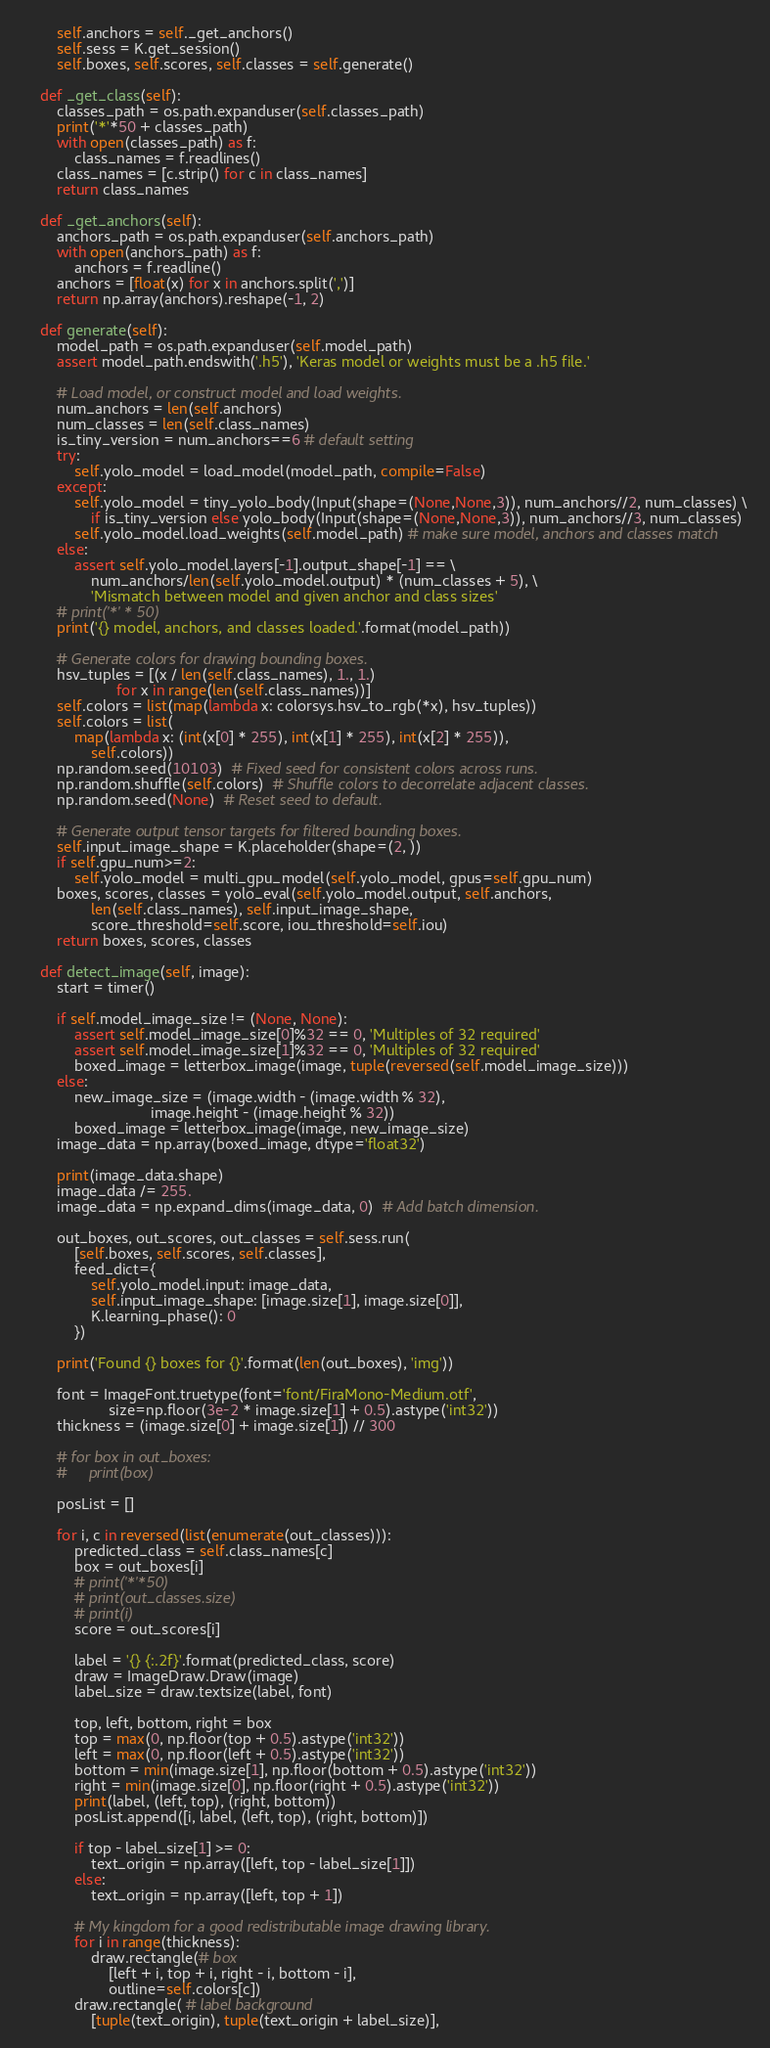Convert code to text. <code><loc_0><loc_0><loc_500><loc_500><_Python_>        self.anchors = self._get_anchors()
        self.sess = K.get_session()
        self.boxes, self.scores, self.classes = self.generate()

    def _get_class(self):
        classes_path = os.path.expanduser(self.classes_path)
        print('*'*50 + classes_path)
        with open(classes_path) as f:
            class_names = f.readlines()
        class_names = [c.strip() for c in class_names]
        return class_names

    def _get_anchors(self):
        anchors_path = os.path.expanduser(self.anchors_path)
        with open(anchors_path) as f:
            anchors = f.readline()
        anchors = [float(x) for x in anchors.split(',')]
        return np.array(anchors).reshape(-1, 2)

    def generate(self):
        model_path = os.path.expanduser(self.model_path)
        assert model_path.endswith('.h5'), 'Keras model or weights must be a .h5 file.'

        # Load model, or construct model and load weights.
        num_anchors = len(self.anchors)
        num_classes = len(self.class_names)
        is_tiny_version = num_anchors==6 # default setting
        try:
            self.yolo_model = load_model(model_path, compile=False)
        except:
            self.yolo_model = tiny_yolo_body(Input(shape=(None,None,3)), num_anchors//2, num_classes) \
                if is_tiny_version else yolo_body(Input(shape=(None,None,3)), num_anchors//3, num_classes)
            self.yolo_model.load_weights(self.model_path) # make sure model, anchors and classes match
        else:
            assert self.yolo_model.layers[-1].output_shape[-1] == \
                num_anchors/len(self.yolo_model.output) * (num_classes + 5), \
                'Mismatch between model and given anchor and class sizes'
        # print('*' * 50)
        print('{} model, anchors, and classes loaded.'.format(model_path))

        # Generate colors for drawing bounding boxes.
        hsv_tuples = [(x / len(self.class_names), 1., 1.)
                      for x in range(len(self.class_names))]
        self.colors = list(map(lambda x: colorsys.hsv_to_rgb(*x), hsv_tuples))
        self.colors = list(
            map(lambda x: (int(x[0] * 255), int(x[1] * 255), int(x[2] * 255)),
                self.colors))
        np.random.seed(10103)  # Fixed seed for consistent colors across runs.
        np.random.shuffle(self.colors)  # Shuffle colors to decorrelate adjacent classes.
        np.random.seed(None)  # Reset seed to default.

        # Generate output tensor targets for filtered bounding boxes.
        self.input_image_shape = K.placeholder(shape=(2, ))
        if self.gpu_num>=2:
            self.yolo_model = multi_gpu_model(self.yolo_model, gpus=self.gpu_num)
        boxes, scores, classes = yolo_eval(self.yolo_model.output, self.anchors,
                len(self.class_names), self.input_image_shape,
                score_threshold=self.score, iou_threshold=self.iou)
        return boxes, scores, classes

    def detect_image(self, image):
        start = timer()

        if self.model_image_size != (None, None):
            assert self.model_image_size[0]%32 == 0, 'Multiples of 32 required'
            assert self.model_image_size[1]%32 == 0, 'Multiples of 32 required'
            boxed_image = letterbox_image(image, tuple(reversed(self.model_image_size)))
        else:
            new_image_size = (image.width - (image.width % 32),
                              image.height - (image.height % 32))
            boxed_image = letterbox_image(image, new_image_size)
        image_data = np.array(boxed_image, dtype='float32')

        print(image_data.shape)
        image_data /= 255.
        image_data = np.expand_dims(image_data, 0)  # Add batch dimension.

        out_boxes, out_scores, out_classes = self.sess.run(
            [self.boxes, self.scores, self.classes],
            feed_dict={
                self.yolo_model.input: image_data,
                self.input_image_shape: [image.size[1], image.size[0]],
                K.learning_phase(): 0
            })

        print('Found {} boxes for {}'.format(len(out_boxes), 'img'))

        font = ImageFont.truetype(font='font/FiraMono-Medium.otf',
                    size=np.floor(3e-2 * image.size[1] + 0.5).astype('int32'))
        thickness = (image.size[0] + image.size[1]) // 300
        
        # for box in out_boxes:
        #     print(box)

        posList = []

        for i, c in reversed(list(enumerate(out_classes))):
            predicted_class = self.class_names[c]
            box = out_boxes[i]
            # print('*'*50)
            # print(out_classes.size)
            # print(i)
            score = out_scores[i]
           
            label = '{} {:.2f}'.format(predicted_class, score)
            draw = ImageDraw.Draw(image)
            label_size = draw.textsize(label, font)

            top, left, bottom, right = box
            top = max(0, np.floor(top + 0.5).astype('int32'))
            left = max(0, np.floor(left + 0.5).astype('int32'))
            bottom = min(image.size[1], np.floor(bottom + 0.5).astype('int32'))
            right = min(image.size[0], np.floor(right + 0.5).astype('int32'))
            print(label, (left, top), (right, bottom))
            posList.append([i, label, (left, top), (right, bottom)])

            if top - label_size[1] >= 0:
                text_origin = np.array([left, top - label_size[1]])
            else:
                text_origin = np.array([left, top + 1])

            # My kingdom for a good redistributable image drawing library.
            for i in range(thickness):
                draw.rectangle(# box
                    [left + i, top + i, right - i, bottom - i],
                    outline=self.colors[c])
            draw.rectangle( # label background
                [tuple(text_origin), tuple(text_origin + label_size)],</code> 